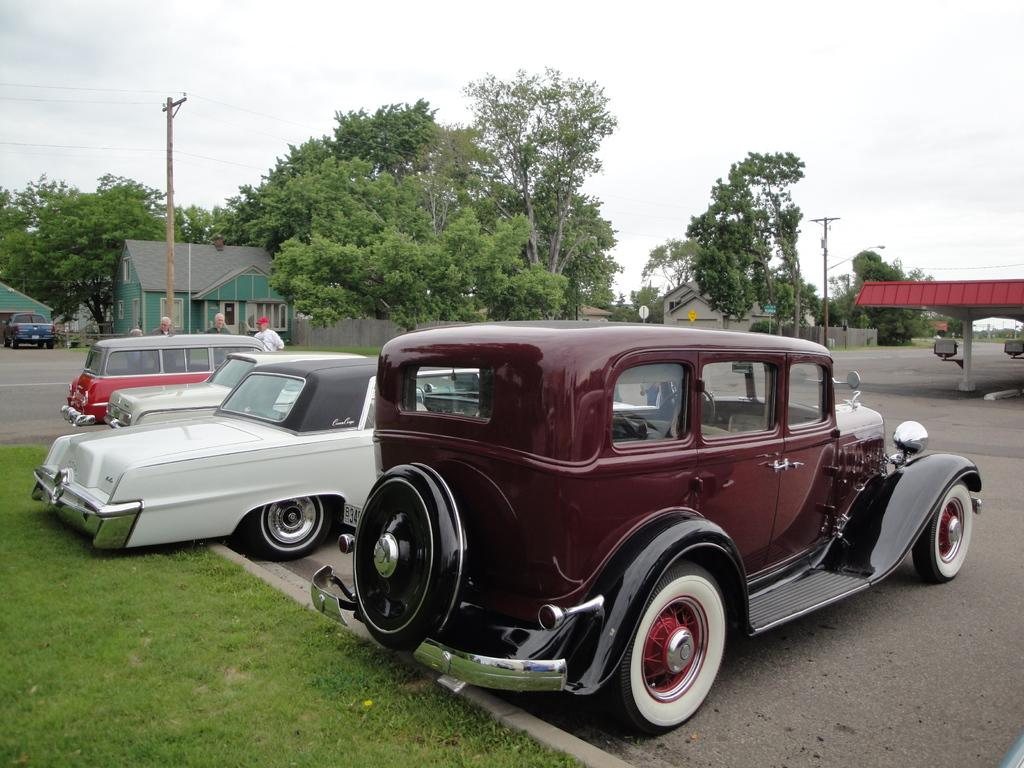What can be seen on the road in the image? There are vehicles on the road in the image. What is visible in the background of the image? Houses, trees, poles, an open shed, a signboard, and people are visible in the background. What is the condition of the sky in the image? The sky is visible in the background, and it is cloudy. How many centimeters is the passenger sitting in the vehicle? There is no information about the passenger or their size in the image, so it cannot be determined. What answer is written on the signboard in the image? There is no information about the content of the signboard in the image, so it cannot be determined. 